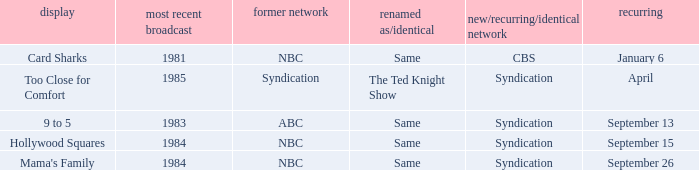What was the earliest aired show that's returning on September 13? 1983.0. 